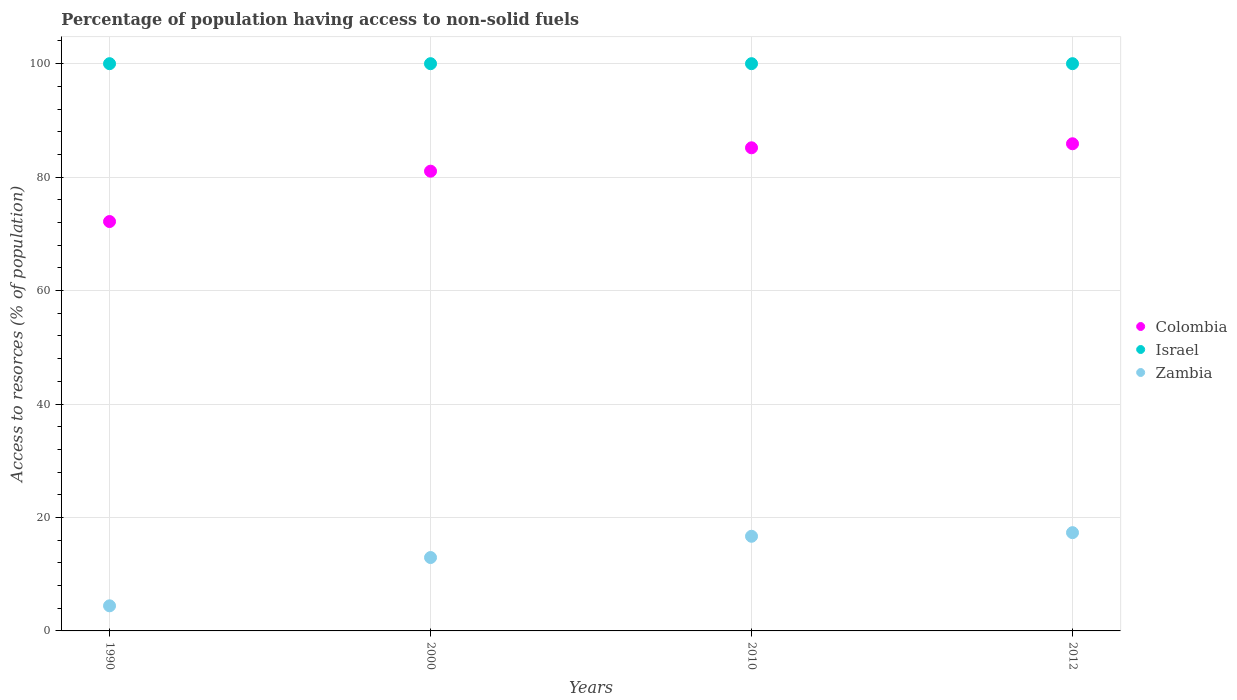What is the percentage of population having access to non-solid fuels in Colombia in 2012?
Your response must be concise. 85.88. Across all years, what is the maximum percentage of population having access to non-solid fuels in Colombia?
Provide a short and direct response. 85.88. Across all years, what is the minimum percentage of population having access to non-solid fuels in Zambia?
Give a very brief answer. 4.42. In which year was the percentage of population having access to non-solid fuels in Colombia maximum?
Give a very brief answer. 2012. In which year was the percentage of population having access to non-solid fuels in Zambia minimum?
Make the answer very short. 1990. What is the total percentage of population having access to non-solid fuels in Zambia in the graph?
Keep it short and to the point. 51.37. What is the difference between the percentage of population having access to non-solid fuels in Israel in 1990 and that in 2012?
Ensure brevity in your answer.  0. What is the difference between the percentage of population having access to non-solid fuels in Colombia in 2000 and the percentage of population having access to non-solid fuels in Zambia in 2012?
Provide a succinct answer. 63.73. What is the average percentage of population having access to non-solid fuels in Israel per year?
Ensure brevity in your answer.  100. In the year 1990, what is the difference between the percentage of population having access to non-solid fuels in Israel and percentage of population having access to non-solid fuels in Colombia?
Your answer should be compact. 27.83. In how many years, is the percentage of population having access to non-solid fuels in Israel greater than 88 %?
Your response must be concise. 4. What is the ratio of the percentage of population having access to non-solid fuels in Zambia in 2000 to that in 2010?
Offer a very short reply. 0.78. Is the percentage of population having access to non-solid fuels in Colombia in 2010 less than that in 2012?
Make the answer very short. Yes. What is the difference between the highest and the second highest percentage of population having access to non-solid fuels in Zambia?
Your response must be concise. 0.64. What is the difference between the highest and the lowest percentage of population having access to non-solid fuels in Zambia?
Your response must be concise. 12.9. Is the sum of the percentage of population having access to non-solid fuels in Colombia in 1990 and 2010 greater than the maximum percentage of population having access to non-solid fuels in Zambia across all years?
Offer a terse response. Yes. Is it the case that in every year, the sum of the percentage of population having access to non-solid fuels in Israel and percentage of population having access to non-solid fuels in Zambia  is greater than the percentage of population having access to non-solid fuels in Colombia?
Give a very brief answer. Yes. Does the percentage of population having access to non-solid fuels in Zambia monotonically increase over the years?
Offer a very short reply. Yes. Is the percentage of population having access to non-solid fuels in Colombia strictly greater than the percentage of population having access to non-solid fuels in Israel over the years?
Ensure brevity in your answer.  No. How many dotlines are there?
Offer a terse response. 3. How many years are there in the graph?
Ensure brevity in your answer.  4. Does the graph contain grids?
Provide a succinct answer. Yes. Where does the legend appear in the graph?
Make the answer very short. Center right. How many legend labels are there?
Make the answer very short. 3. How are the legend labels stacked?
Provide a short and direct response. Vertical. What is the title of the graph?
Provide a succinct answer. Percentage of population having access to non-solid fuels. Does "South Africa" appear as one of the legend labels in the graph?
Give a very brief answer. No. What is the label or title of the Y-axis?
Offer a terse response. Access to resorces (% of population). What is the Access to resorces (% of population) in Colombia in 1990?
Ensure brevity in your answer.  72.17. What is the Access to resorces (% of population) of Zambia in 1990?
Offer a very short reply. 4.42. What is the Access to resorces (% of population) of Colombia in 2000?
Ensure brevity in your answer.  81.05. What is the Access to resorces (% of population) in Israel in 2000?
Provide a succinct answer. 100. What is the Access to resorces (% of population) of Zambia in 2000?
Provide a short and direct response. 12.94. What is the Access to resorces (% of population) of Colombia in 2010?
Your answer should be very brief. 85.17. What is the Access to resorces (% of population) in Israel in 2010?
Offer a very short reply. 100. What is the Access to resorces (% of population) in Zambia in 2010?
Provide a succinct answer. 16.69. What is the Access to resorces (% of population) in Colombia in 2012?
Provide a short and direct response. 85.88. What is the Access to resorces (% of population) in Israel in 2012?
Keep it short and to the point. 100. What is the Access to resorces (% of population) in Zambia in 2012?
Your response must be concise. 17.32. Across all years, what is the maximum Access to resorces (% of population) of Colombia?
Offer a very short reply. 85.88. Across all years, what is the maximum Access to resorces (% of population) in Zambia?
Your answer should be very brief. 17.32. Across all years, what is the minimum Access to resorces (% of population) of Colombia?
Your response must be concise. 72.17. Across all years, what is the minimum Access to resorces (% of population) of Zambia?
Offer a very short reply. 4.42. What is the total Access to resorces (% of population) in Colombia in the graph?
Make the answer very short. 324.27. What is the total Access to resorces (% of population) in Zambia in the graph?
Offer a terse response. 51.37. What is the difference between the Access to resorces (% of population) of Colombia in 1990 and that in 2000?
Keep it short and to the point. -8.88. What is the difference between the Access to resorces (% of population) of Zambia in 1990 and that in 2000?
Offer a very short reply. -8.51. What is the difference between the Access to resorces (% of population) in Colombia in 1990 and that in 2010?
Offer a terse response. -13. What is the difference between the Access to resorces (% of population) in Israel in 1990 and that in 2010?
Offer a terse response. 0. What is the difference between the Access to resorces (% of population) in Zambia in 1990 and that in 2010?
Offer a very short reply. -12.26. What is the difference between the Access to resorces (% of population) in Colombia in 1990 and that in 2012?
Provide a succinct answer. -13.71. What is the difference between the Access to resorces (% of population) of Zambia in 1990 and that in 2012?
Ensure brevity in your answer.  -12.9. What is the difference between the Access to resorces (% of population) in Colombia in 2000 and that in 2010?
Give a very brief answer. -4.12. What is the difference between the Access to resorces (% of population) of Zambia in 2000 and that in 2010?
Make the answer very short. -3.75. What is the difference between the Access to resorces (% of population) of Colombia in 2000 and that in 2012?
Your answer should be compact. -4.83. What is the difference between the Access to resorces (% of population) of Zambia in 2000 and that in 2012?
Provide a succinct answer. -4.38. What is the difference between the Access to resorces (% of population) in Colombia in 2010 and that in 2012?
Offer a terse response. -0.71. What is the difference between the Access to resorces (% of population) in Zambia in 2010 and that in 2012?
Keep it short and to the point. -0.64. What is the difference between the Access to resorces (% of population) in Colombia in 1990 and the Access to resorces (% of population) in Israel in 2000?
Ensure brevity in your answer.  -27.83. What is the difference between the Access to resorces (% of population) in Colombia in 1990 and the Access to resorces (% of population) in Zambia in 2000?
Your response must be concise. 59.23. What is the difference between the Access to resorces (% of population) in Israel in 1990 and the Access to resorces (% of population) in Zambia in 2000?
Keep it short and to the point. 87.06. What is the difference between the Access to resorces (% of population) in Colombia in 1990 and the Access to resorces (% of population) in Israel in 2010?
Provide a short and direct response. -27.83. What is the difference between the Access to resorces (% of population) in Colombia in 1990 and the Access to resorces (% of population) in Zambia in 2010?
Keep it short and to the point. 55.49. What is the difference between the Access to resorces (% of population) of Israel in 1990 and the Access to resorces (% of population) of Zambia in 2010?
Make the answer very short. 83.31. What is the difference between the Access to resorces (% of population) of Colombia in 1990 and the Access to resorces (% of population) of Israel in 2012?
Provide a succinct answer. -27.83. What is the difference between the Access to resorces (% of population) of Colombia in 1990 and the Access to resorces (% of population) of Zambia in 2012?
Give a very brief answer. 54.85. What is the difference between the Access to resorces (% of population) of Israel in 1990 and the Access to resorces (% of population) of Zambia in 2012?
Provide a succinct answer. 82.68. What is the difference between the Access to resorces (% of population) in Colombia in 2000 and the Access to resorces (% of population) in Israel in 2010?
Provide a succinct answer. -18.95. What is the difference between the Access to resorces (% of population) of Colombia in 2000 and the Access to resorces (% of population) of Zambia in 2010?
Your answer should be very brief. 64.36. What is the difference between the Access to resorces (% of population) in Israel in 2000 and the Access to resorces (% of population) in Zambia in 2010?
Your answer should be very brief. 83.31. What is the difference between the Access to resorces (% of population) in Colombia in 2000 and the Access to resorces (% of population) in Israel in 2012?
Keep it short and to the point. -18.95. What is the difference between the Access to resorces (% of population) of Colombia in 2000 and the Access to resorces (% of population) of Zambia in 2012?
Provide a succinct answer. 63.73. What is the difference between the Access to resorces (% of population) in Israel in 2000 and the Access to resorces (% of population) in Zambia in 2012?
Make the answer very short. 82.68. What is the difference between the Access to resorces (% of population) of Colombia in 2010 and the Access to resorces (% of population) of Israel in 2012?
Your response must be concise. -14.83. What is the difference between the Access to resorces (% of population) of Colombia in 2010 and the Access to resorces (% of population) of Zambia in 2012?
Give a very brief answer. 67.85. What is the difference between the Access to resorces (% of population) in Israel in 2010 and the Access to resorces (% of population) in Zambia in 2012?
Your answer should be compact. 82.68. What is the average Access to resorces (% of population) in Colombia per year?
Make the answer very short. 81.07. What is the average Access to resorces (% of population) of Israel per year?
Offer a terse response. 100. What is the average Access to resorces (% of population) in Zambia per year?
Your answer should be compact. 12.84. In the year 1990, what is the difference between the Access to resorces (% of population) of Colombia and Access to resorces (% of population) of Israel?
Provide a short and direct response. -27.83. In the year 1990, what is the difference between the Access to resorces (% of population) of Colombia and Access to resorces (% of population) of Zambia?
Offer a terse response. 67.75. In the year 1990, what is the difference between the Access to resorces (% of population) of Israel and Access to resorces (% of population) of Zambia?
Give a very brief answer. 95.58. In the year 2000, what is the difference between the Access to resorces (% of population) in Colombia and Access to resorces (% of population) in Israel?
Offer a terse response. -18.95. In the year 2000, what is the difference between the Access to resorces (% of population) in Colombia and Access to resorces (% of population) in Zambia?
Make the answer very short. 68.11. In the year 2000, what is the difference between the Access to resorces (% of population) of Israel and Access to resorces (% of population) of Zambia?
Keep it short and to the point. 87.06. In the year 2010, what is the difference between the Access to resorces (% of population) of Colombia and Access to resorces (% of population) of Israel?
Provide a succinct answer. -14.83. In the year 2010, what is the difference between the Access to resorces (% of population) of Colombia and Access to resorces (% of population) of Zambia?
Give a very brief answer. 68.48. In the year 2010, what is the difference between the Access to resorces (% of population) of Israel and Access to resorces (% of population) of Zambia?
Make the answer very short. 83.31. In the year 2012, what is the difference between the Access to resorces (% of population) in Colombia and Access to resorces (% of population) in Israel?
Provide a short and direct response. -14.12. In the year 2012, what is the difference between the Access to resorces (% of population) in Colombia and Access to resorces (% of population) in Zambia?
Keep it short and to the point. 68.56. In the year 2012, what is the difference between the Access to resorces (% of population) of Israel and Access to resorces (% of population) of Zambia?
Make the answer very short. 82.68. What is the ratio of the Access to resorces (% of population) in Colombia in 1990 to that in 2000?
Provide a succinct answer. 0.89. What is the ratio of the Access to resorces (% of population) of Israel in 1990 to that in 2000?
Ensure brevity in your answer.  1. What is the ratio of the Access to resorces (% of population) in Zambia in 1990 to that in 2000?
Offer a terse response. 0.34. What is the ratio of the Access to resorces (% of population) in Colombia in 1990 to that in 2010?
Make the answer very short. 0.85. What is the ratio of the Access to resorces (% of population) in Zambia in 1990 to that in 2010?
Offer a terse response. 0.27. What is the ratio of the Access to resorces (% of population) in Colombia in 1990 to that in 2012?
Give a very brief answer. 0.84. What is the ratio of the Access to resorces (% of population) of Zambia in 1990 to that in 2012?
Provide a short and direct response. 0.26. What is the ratio of the Access to resorces (% of population) of Colombia in 2000 to that in 2010?
Give a very brief answer. 0.95. What is the ratio of the Access to resorces (% of population) in Zambia in 2000 to that in 2010?
Provide a short and direct response. 0.78. What is the ratio of the Access to resorces (% of population) in Colombia in 2000 to that in 2012?
Provide a short and direct response. 0.94. What is the ratio of the Access to resorces (% of population) of Zambia in 2000 to that in 2012?
Keep it short and to the point. 0.75. What is the ratio of the Access to resorces (% of population) in Colombia in 2010 to that in 2012?
Make the answer very short. 0.99. What is the ratio of the Access to resorces (% of population) in Israel in 2010 to that in 2012?
Offer a terse response. 1. What is the ratio of the Access to resorces (% of population) of Zambia in 2010 to that in 2012?
Provide a short and direct response. 0.96. What is the difference between the highest and the second highest Access to resorces (% of population) in Colombia?
Keep it short and to the point. 0.71. What is the difference between the highest and the second highest Access to resorces (% of population) of Zambia?
Your answer should be very brief. 0.64. What is the difference between the highest and the lowest Access to resorces (% of population) of Colombia?
Your answer should be compact. 13.71. What is the difference between the highest and the lowest Access to resorces (% of population) in Israel?
Offer a very short reply. 0. What is the difference between the highest and the lowest Access to resorces (% of population) in Zambia?
Provide a succinct answer. 12.9. 